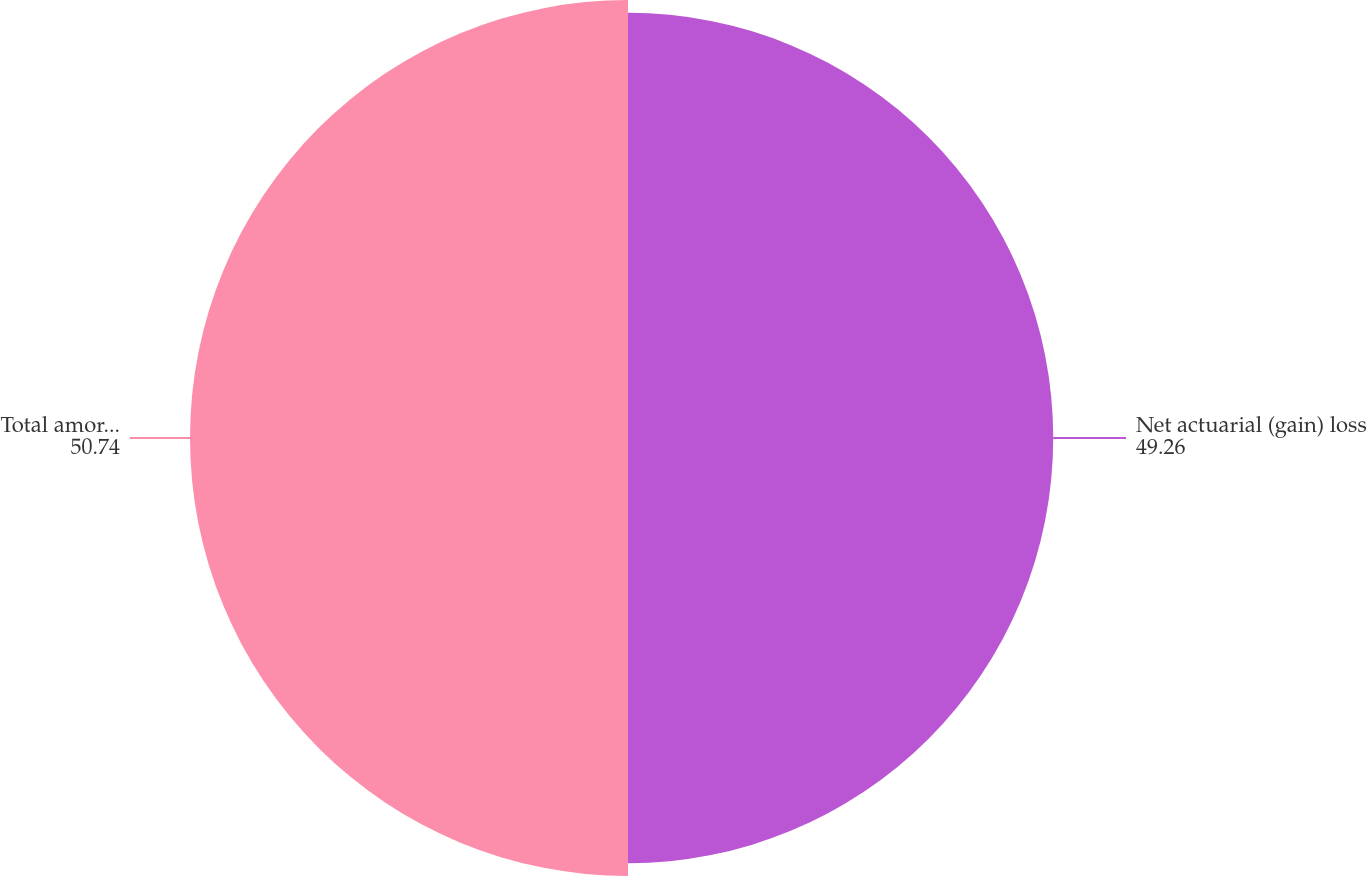<chart> <loc_0><loc_0><loc_500><loc_500><pie_chart><fcel>Net actuarial (gain) loss<fcel>Total amortized from<nl><fcel>49.26%<fcel>50.74%<nl></chart> 